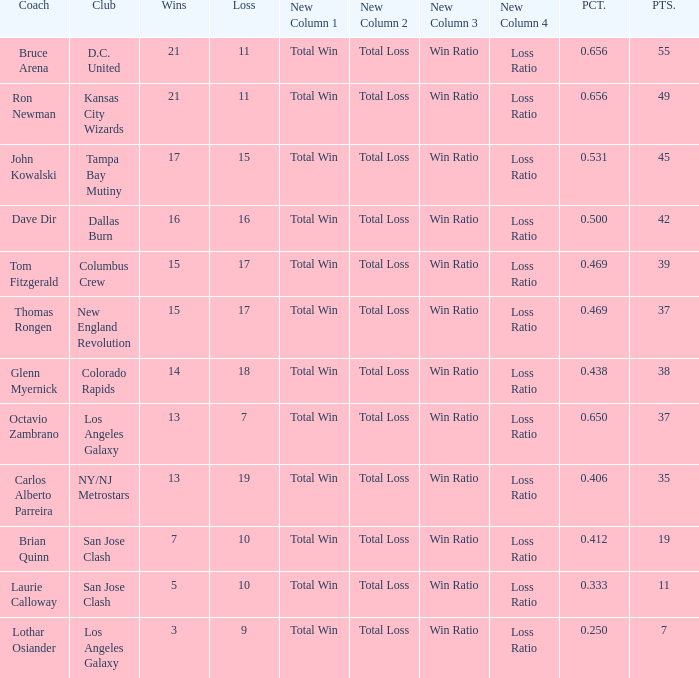What is the highest percent of Bruce Arena when he loses more than 11 games? None. Would you be able to parse every entry in this table? {'header': ['Coach', 'Club', 'Wins', 'Loss', 'New Column 1', 'New Column 2', 'New Column 3', 'New Column 4', 'PCT.', 'PTS.'], 'rows': [['Bruce Arena', 'D.C. United', '21', '11', 'Total Win', 'Total Loss', 'Win Ratio', 'Loss Ratio', '0.656', '55'], ['Ron Newman', 'Kansas City Wizards', '21', '11', 'Total Win', 'Total Loss', 'Win Ratio', 'Loss Ratio', '0.656', '49'], ['John Kowalski', 'Tampa Bay Mutiny', '17', '15', 'Total Win', 'Total Loss', 'Win Ratio', 'Loss Ratio', '0.531', '45'], ['Dave Dir', 'Dallas Burn', '16', '16', 'Total Win', 'Total Loss', 'Win Ratio', 'Loss Ratio', '0.500', '42'], ['Tom Fitzgerald', 'Columbus Crew', '15', '17', 'Total Win', 'Total Loss', 'Win Ratio', 'Loss Ratio', '0.469', '39'], ['Thomas Rongen', 'New England Revolution', '15', '17', 'Total Win', 'Total Loss', 'Win Ratio', 'Loss Ratio', '0.469', '37'], ['Glenn Myernick', 'Colorado Rapids', '14', '18', 'Total Win', 'Total Loss', 'Win Ratio', 'Loss Ratio', '0.438', '38'], ['Octavio Zambrano', 'Los Angeles Galaxy', '13', '7', 'Total Win', 'Total Loss', 'Win Ratio', 'Loss Ratio', '0.650', '37'], ['Carlos Alberto Parreira', 'NY/NJ Metrostars', '13', '19', 'Total Win', 'Total Loss', 'Win Ratio', 'Loss Ratio', '0.406', '35'], ['Brian Quinn', 'San Jose Clash', '7', '10', 'Total Win', 'Total Loss', 'Win Ratio', 'Loss Ratio', '0.412', '19'], ['Laurie Calloway', 'San Jose Clash', '5', '10', 'Total Win', 'Total Loss', 'Win Ratio', 'Loss Ratio', '0.333', '11'], ['Lothar Osiander', 'Los Angeles Galaxy', '3', '9', 'Total Win', 'Total Loss', 'Win Ratio', 'Loss Ratio', '0.250', '7']]} 